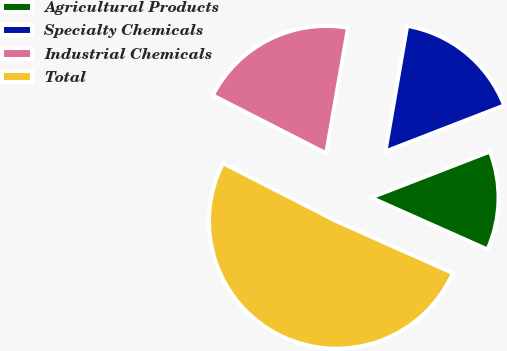<chart> <loc_0><loc_0><loc_500><loc_500><pie_chart><fcel>Agricultural Products<fcel>Specialty Chemicals<fcel>Industrial Chemicals<fcel>Total<nl><fcel>12.55%<fcel>16.38%<fcel>20.21%<fcel>50.86%<nl></chart> 